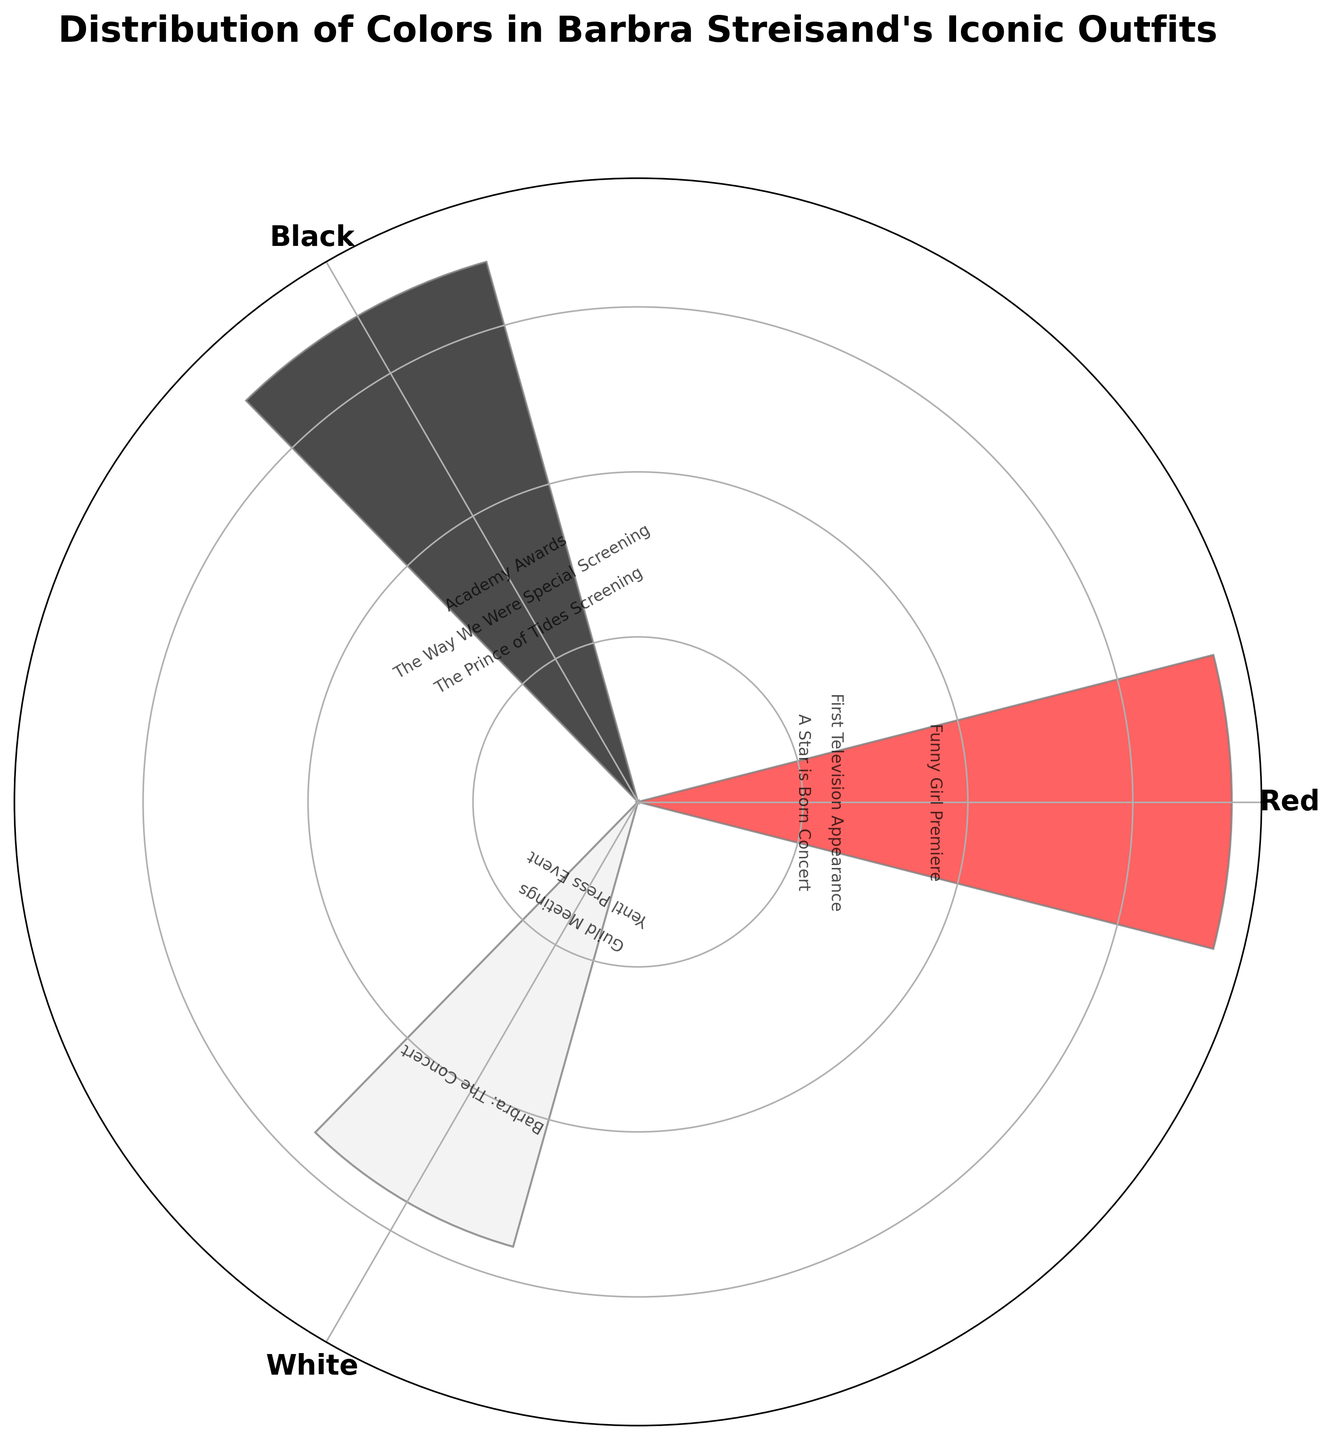What's the title of the chart? The title is displayed at the top of the chart and it is the largest text element present.
Answer: Distribution of Colors in Barbra Streisand's Iconic Outfits How many colors are represented in the chart? The chart uses distinct bars for each color group. By counting unique colors on the labels around the chart, we can see there are three colors.
Answer: 3 Which color has the highest frequency? By looking at the height of each bar in the chart, we see the bar representing White extends the highest.
Answer: White What is the total frequency for the color Red? There are three events associated with Red, with frequencies of 5, 8, and 4. Summing these gives 5 + 8 + 4.
Answer: 17 Comparing the color Black and White, which one appears more frequently? The bar for White is higher than the bar for Black, indicating White appears more frequently.
Answer: White What is the sum of the frequencies for Black? To find the sum, add the frequencies associated with Black, which are 7, 5, and 6. Therefore, 7 + 5 + 6.
Answer: 18 On how many different events has Barbara worn White? By counting event labels associated with White, we see there are three events: "Barbra: The Concert", "Guild Meetings", and "Yentl Press Event".
Answer: 3 Which event had the highest frequency for any color, and what was that frequency? The height of the bar indicates frequency. The "Barbra: The Concert" event for White has the highest frequency of 9.
Answer: "Barbra: The Concert", 9 